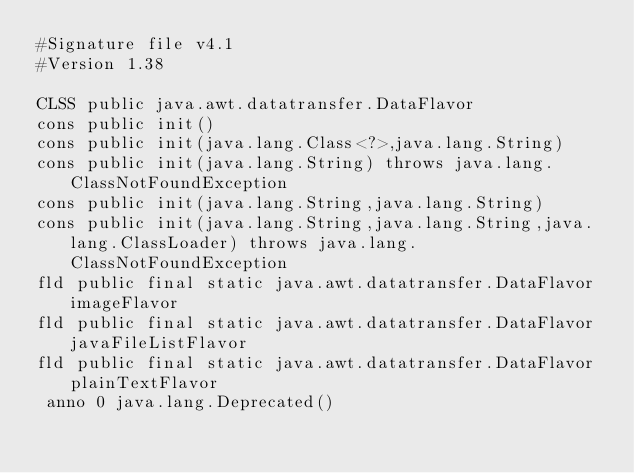<code> <loc_0><loc_0><loc_500><loc_500><_SML_>#Signature file v4.1
#Version 1.38

CLSS public java.awt.datatransfer.DataFlavor
cons public init()
cons public init(java.lang.Class<?>,java.lang.String)
cons public init(java.lang.String) throws java.lang.ClassNotFoundException
cons public init(java.lang.String,java.lang.String)
cons public init(java.lang.String,java.lang.String,java.lang.ClassLoader) throws java.lang.ClassNotFoundException
fld public final static java.awt.datatransfer.DataFlavor imageFlavor
fld public final static java.awt.datatransfer.DataFlavor javaFileListFlavor
fld public final static java.awt.datatransfer.DataFlavor plainTextFlavor
 anno 0 java.lang.Deprecated()</code> 